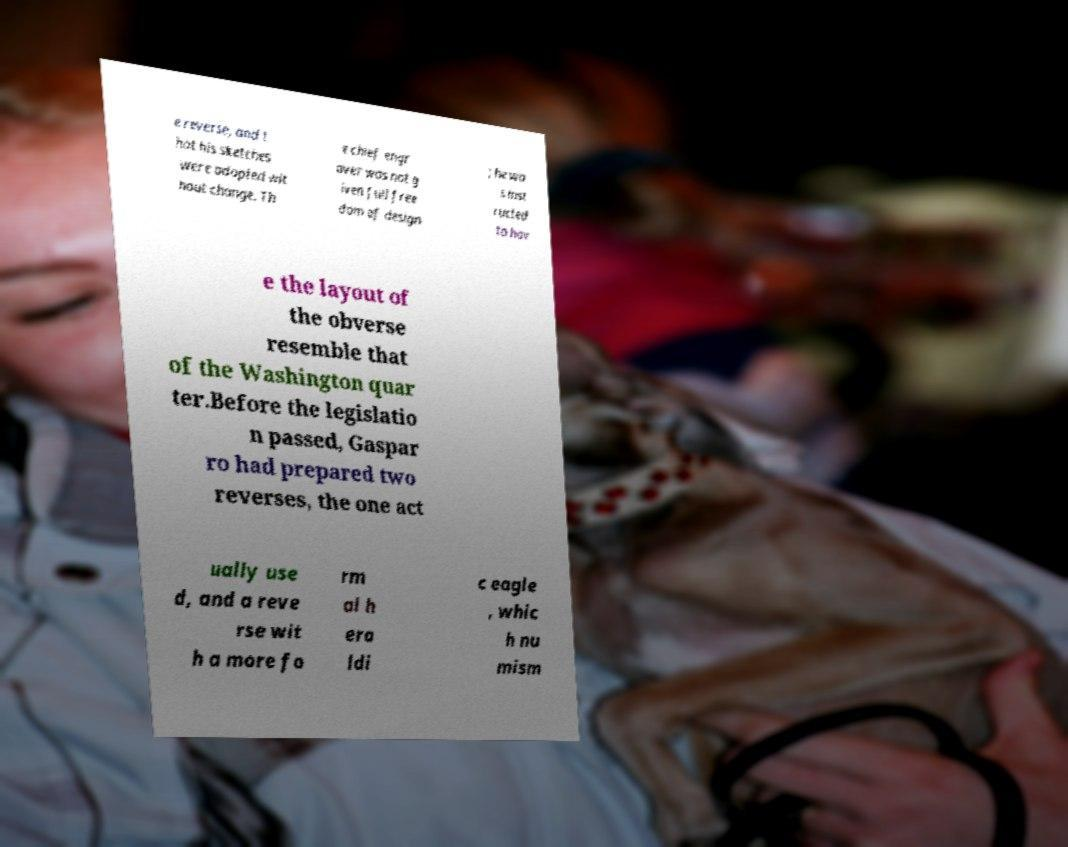Please read and relay the text visible in this image. What does it say? e reverse, and t hat his sketches were adopted wit hout change. Th e chief engr aver was not g iven full free dom of design ; he wa s inst ructed to hav e the layout of the obverse resemble that of the Washington quar ter.Before the legislatio n passed, Gaspar ro had prepared two reverses, the one act ually use d, and a reve rse wit h a more fo rm al h era ldi c eagle , whic h nu mism 